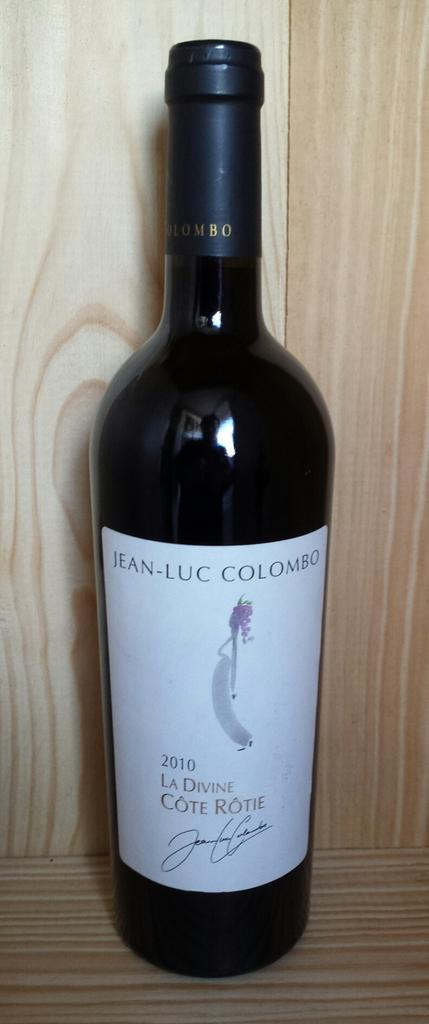<image>
Render a clear and concise summary of the photo. A 2010 bottle of La Divine Cote Rotie stands on a wood shelf. 